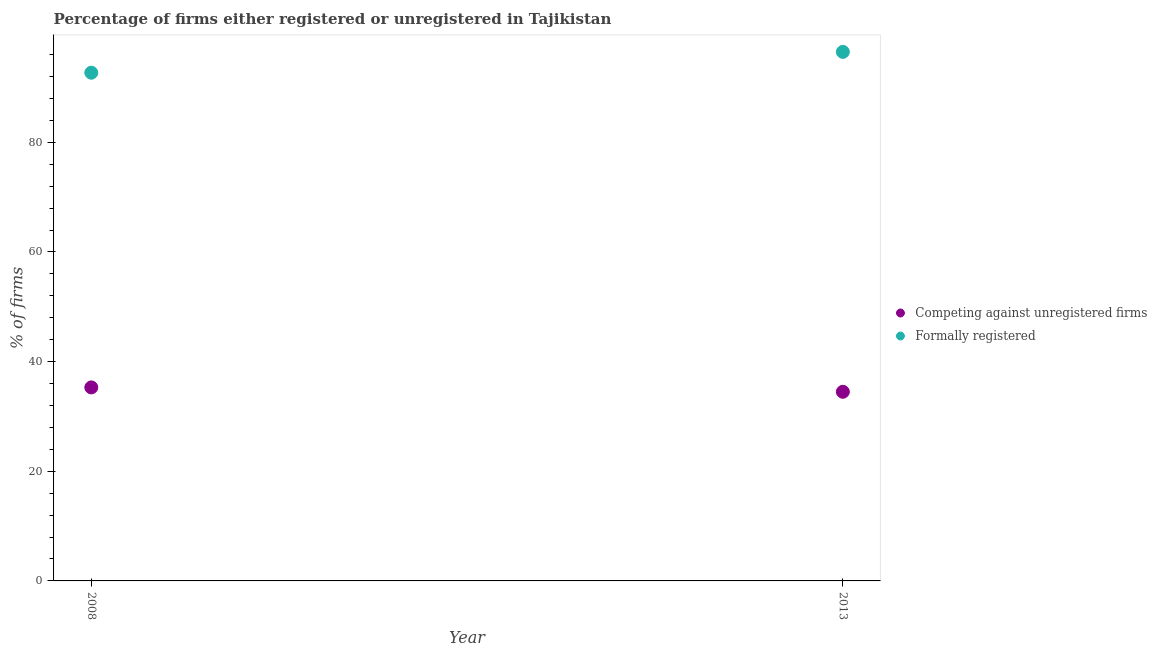How many different coloured dotlines are there?
Offer a very short reply. 2. Is the number of dotlines equal to the number of legend labels?
Provide a short and direct response. Yes. What is the percentage of registered firms in 2008?
Provide a short and direct response. 35.3. Across all years, what is the maximum percentage of formally registered firms?
Give a very brief answer. 96.5. Across all years, what is the minimum percentage of formally registered firms?
Ensure brevity in your answer.  92.7. In which year was the percentage of registered firms maximum?
Offer a very short reply. 2008. What is the total percentage of formally registered firms in the graph?
Your response must be concise. 189.2. What is the difference between the percentage of formally registered firms in 2008 and that in 2013?
Your answer should be compact. -3.8. What is the difference between the percentage of formally registered firms in 2013 and the percentage of registered firms in 2008?
Offer a very short reply. 61.2. What is the average percentage of registered firms per year?
Offer a terse response. 34.9. In the year 2008, what is the difference between the percentage of registered firms and percentage of formally registered firms?
Offer a very short reply. -57.4. In how many years, is the percentage of formally registered firms greater than 12 %?
Offer a terse response. 2. What is the ratio of the percentage of formally registered firms in 2008 to that in 2013?
Your response must be concise. 0.96. Is the percentage of registered firms in 2008 less than that in 2013?
Give a very brief answer. No. In how many years, is the percentage of formally registered firms greater than the average percentage of formally registered firms taken over all years?
Provide a short and direct response. 1. Does the percentage of formally registered firms monotonically increase over the years?
Provide a succinct answer. Yes. Is the percentage of registered firms strictly less than the percentage of formally registered firms over the years?
Provide a short and direct response. Yes. What is the difference between two consecutive major ticks on the Y-axis?
Your answer should be compact. 20. Does the graph contain grids?
Give a very brief answer. No. How many legend labels are there?
Give a very brief answer. 2. What is the title of the graph?
Give a very brief answer. Percentage of firms either registered or unregistered in Tajikistan. Does "Ages 15-24" appear as one of the legend labels in the graph?
Ensure brevity in your answer.  No. What is the label or title of the X-axis?
Offer a very short reply. Year. What is the label or title of the Y-axis?
Your answer should be very brief. % of firms. What is the % of firms in Competing against unregistered firms in 2008?
Offer a very short reply. 35.3. What is the % of firms in Formally registered in 2008?
Offer a very short reply. 92.7. What is the % of firms of Competing against unregistered firms in 2013?
Keep it short and to the point. 34.5. What is the % of firms in Formally registered in 2013?
Make the answer very short. 96.5. Across all years, what is the maximum % of firms of Competing against unregistered firms?
Keep it short and to the point. 35.3. Across all years, what is the maximum % of firms in Formally registered?
Offer a very short reply. 96.5. Across all years, what is the minimum % of firms in Competing against unregistered firms?
Provide a short and direct response. 34.5. Across all years, what is the minimum % of firms in Formally registered?
Provide a succinct answer. 92.7. What is the total % of firms in Competing against unregistered firms in the graph?
Your answer should be very brief. 69.8. What is the total % of firms of Formally registered in the graph?
Your answer should be compact. 189.2. What is the difference between the % of firms of Competing against unregistered firms in 2008 and that in 2013?
Your answer should be compact. 0.8. What is the difference between the % of firms in Formally registered in 2008 and that in 2013?
Your answer should be very brief. -3.8. What is the difference between the % of firms in Competing against unregistered firms in 2008 and the % of firms in Formally registered in 2013?
Offer a terse response. -61.2. What is the average % of firms of Competing against unregistered firms per year?
Your answer should be very brief. 34.9. What is the average % of firms in Formally registered per year?
Give a very brief answer. 94.6. In the year 2008, what is the difference between the % of firms in Competing against unregistered firms and % of firms in Formally registered?
Offer a very short reply. -57.4. In the year 2013, what is the difference between the % of firms of Competing against unregistered firms and % of firms of Formally registered?
Your response must be concise. -62. What is the ratio of the % of firms of Competing against unregistered firms in 2008 to that in 2013?
Your answer should be compact. 1.02. What is the ratio of the % of firms of Formally registered in 2008 to that in 2013?
Your response must be concise. 0.96. What is the difference between the highest and the second highest % of firms of Formally registered?
Keep it short and to the point. 3.8. What is the difference between the highest and the lowest % of firms of Competing against unregistered firms?
Make the answer very short. 0.8. What is the difference between the highest and the lowest % of firms in Formally registered?
Offer a terse response. 3.8. 